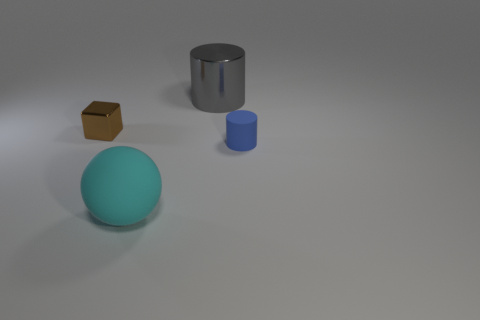Subtract all gray cylinders. How many cylinders are left? 1 Add 2 rubber cylinders. How many objects exist? 6 Subtract 1 cubes. How many cubes are left? 0 Subtract all purple cylinders. How many purple blocks are left? 0 Subtract all spheres. Subtract all tiny brown shiny objects. How many objects are left? 2 Add 4 cyan balls. How many cyan balls are left? 5 Add 2 big gray cylinders. How many big gray cylinders exist? 3 Subtract 0 cyan cubes. How many objects are left? 4 Subtract all blocks. How many objects are left? 3 Subtract all purple cylinders. Subtract all gray spheres. How many cylinders are left? 2 